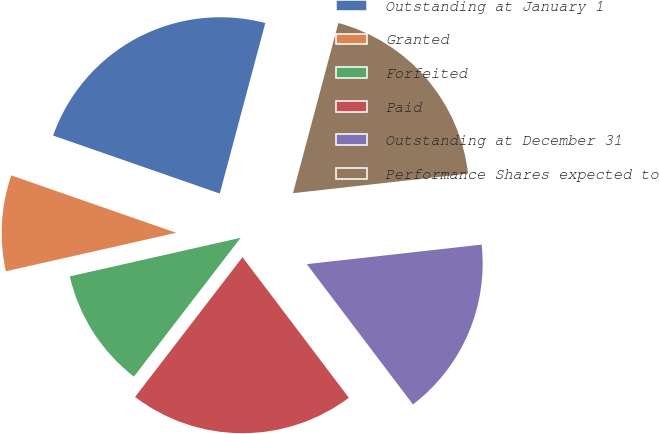<chart> <loc_0><loc_0><loc_500><loc_500><pie_chart><fcel>Outstanding at January 1<fcel>Granted<fcel>Forfeited<fcel>Paid<fcel>Outstanding at December 31<fcel>Performance Shares expected to<nl><fcel>23.82%<fcel>8.87%<fcel>11.03%<fcel>20.74%<fcel>16.46%<fcel>19.08%<nl></chart> 